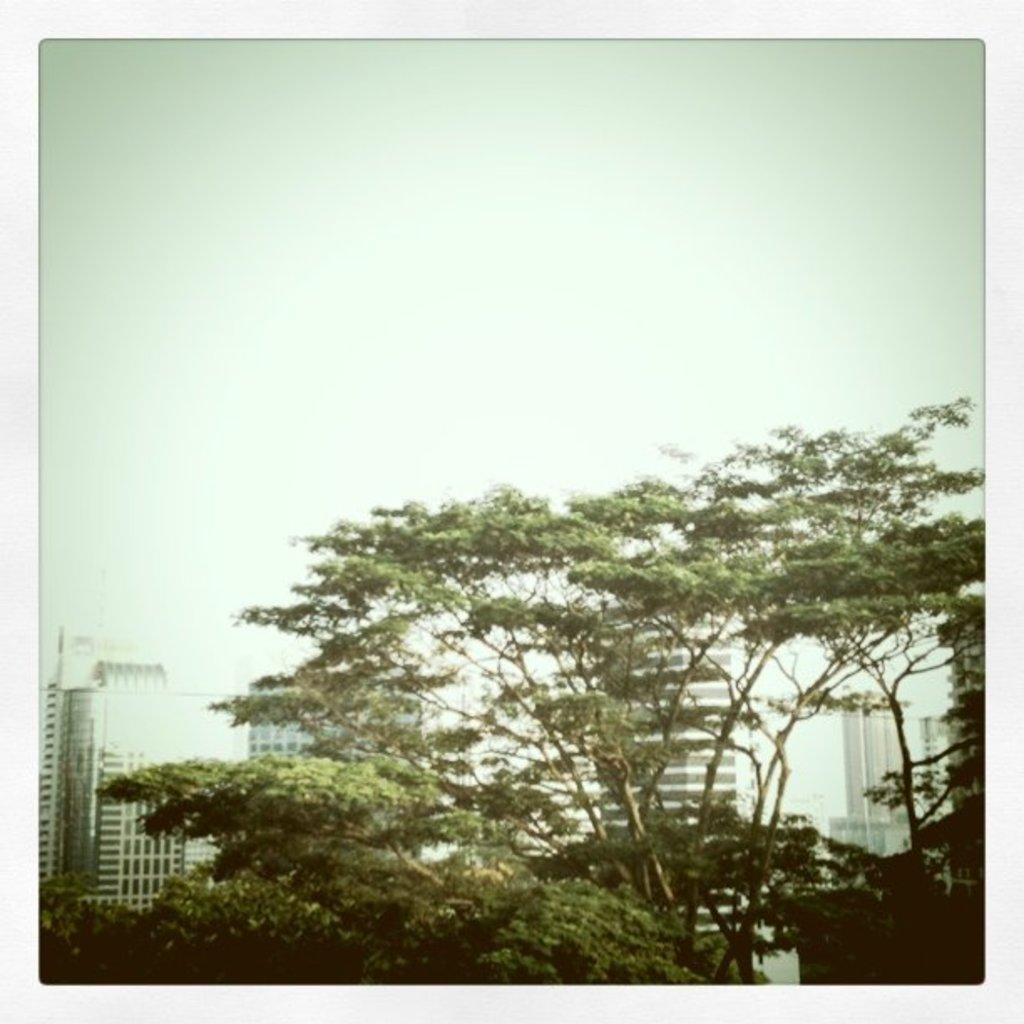What type of natural elements can be seen in the image? There are trees in the image. What type of man-made structures are visible in the background? There are buildings in the background of the image. What part of the natural environment is visible in the image? The sky is visible in the background of the image. How is the image framed or contained? The image has borders. What type of ornament is the judge holding in the image? There is no judge or ornament present in the image. What scientific experiment is being conducted in the image? There is no scientific experiment or related objects present in the image. 